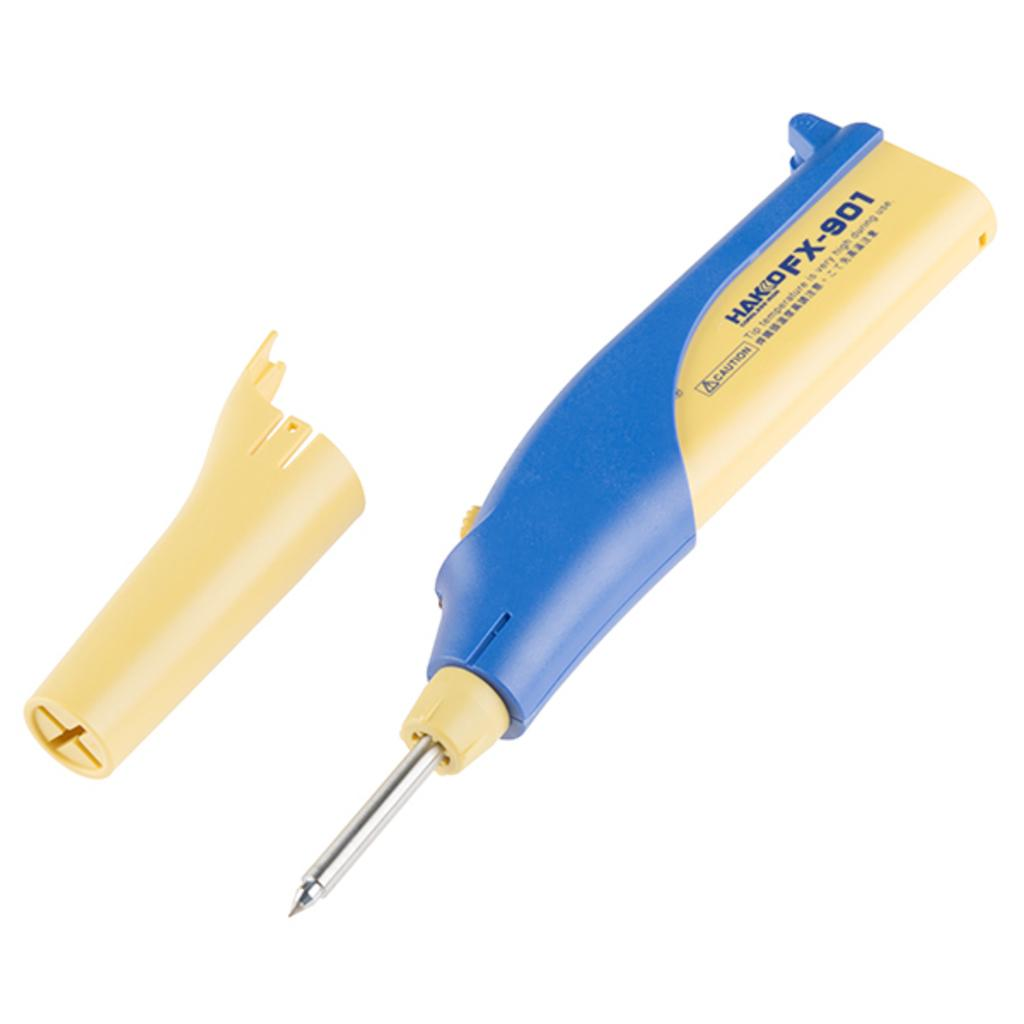What tool is visible in the image? There is a soldering iron in the image. What colors can be seen on the soldering iron? The soldering iron has yellow and blue colors. What part of the soldering iron has a yellow color? There is a yellow color cap of the soldering iron in the image. What type of weather can be seen in the image? There is no weather or outdoor scene present in the image; it features a soldering iron with a yellow and blue color scheme. Can you compare the soldering iron to a different tool in the image? There is no other tool present in the image to compare the soldering iron to. 